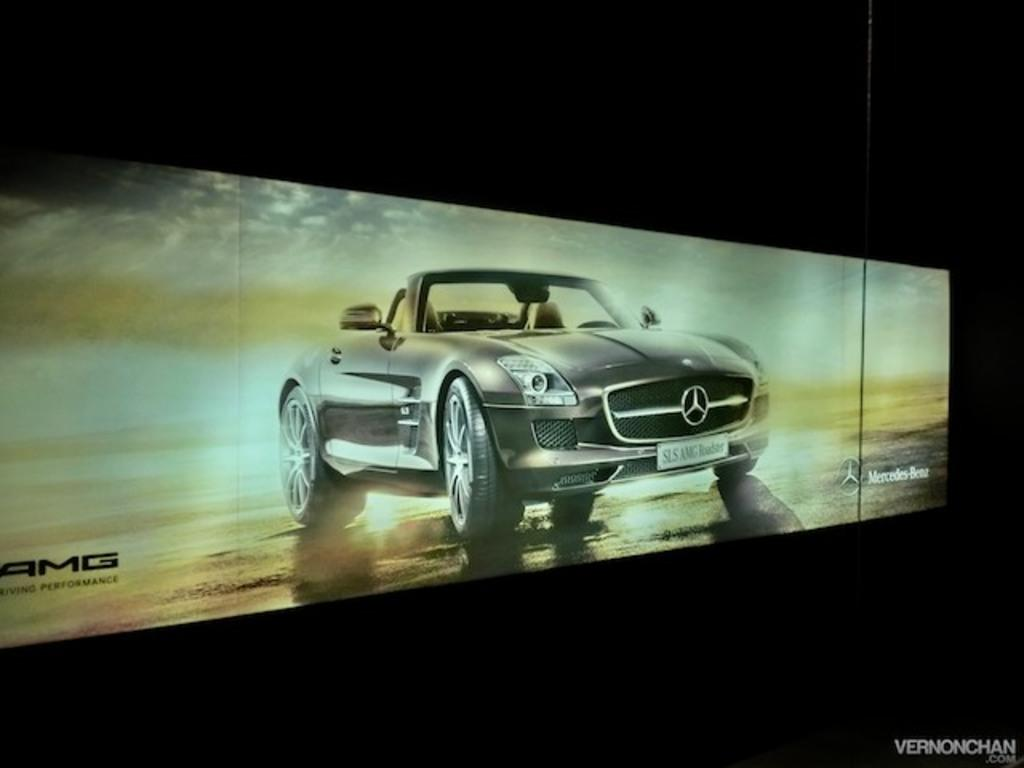What is the main object in the image? There is a display screen in the image. What is being displayed on the screen? The display screen shows a car on the road. Are there any words or numbers on the display screen? Yes, there is text visible on the display screen. What can be seen in the background of the image? The sky is visible in the image. How would you describe the weather based on the sky in the image? The sky appears cloudy in the image, suggesting a potentially overcast or cloudy day. Where is the playground located in the image? There is no playground present in the image. What type of steel is used to construct the fan in the image? A: There is no fan or steel present in the image. 